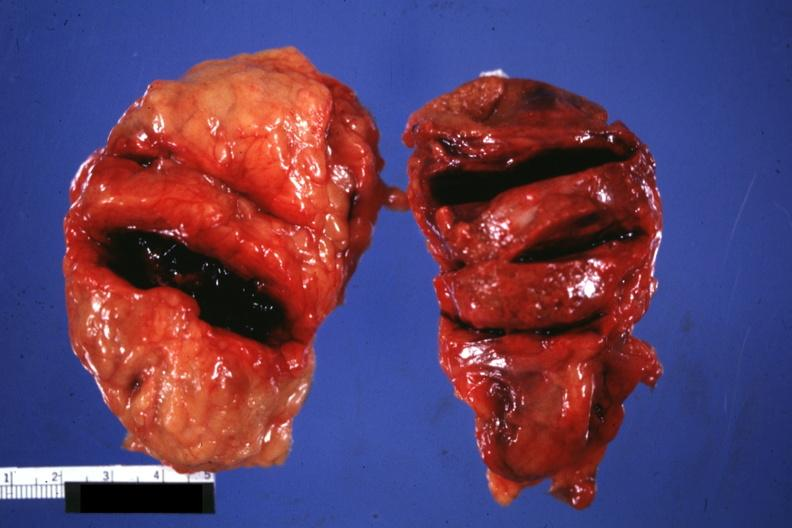what does this image show?
Answer the question using a single word or phrase. External view of gland with knife cuts into parenchyma hemorrhage is obvious 